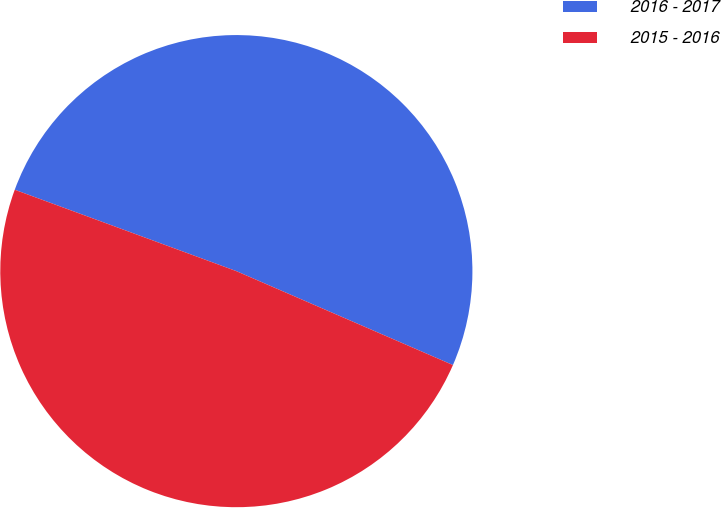Convert chart. <chart><loc_0><loc_0><loc_500><loc_500><pie_chart><fcel>2016 - 2017<fcel>2015 - 2016<nl><fcel>50.91%<fcel>49.09%<nl></chart> 